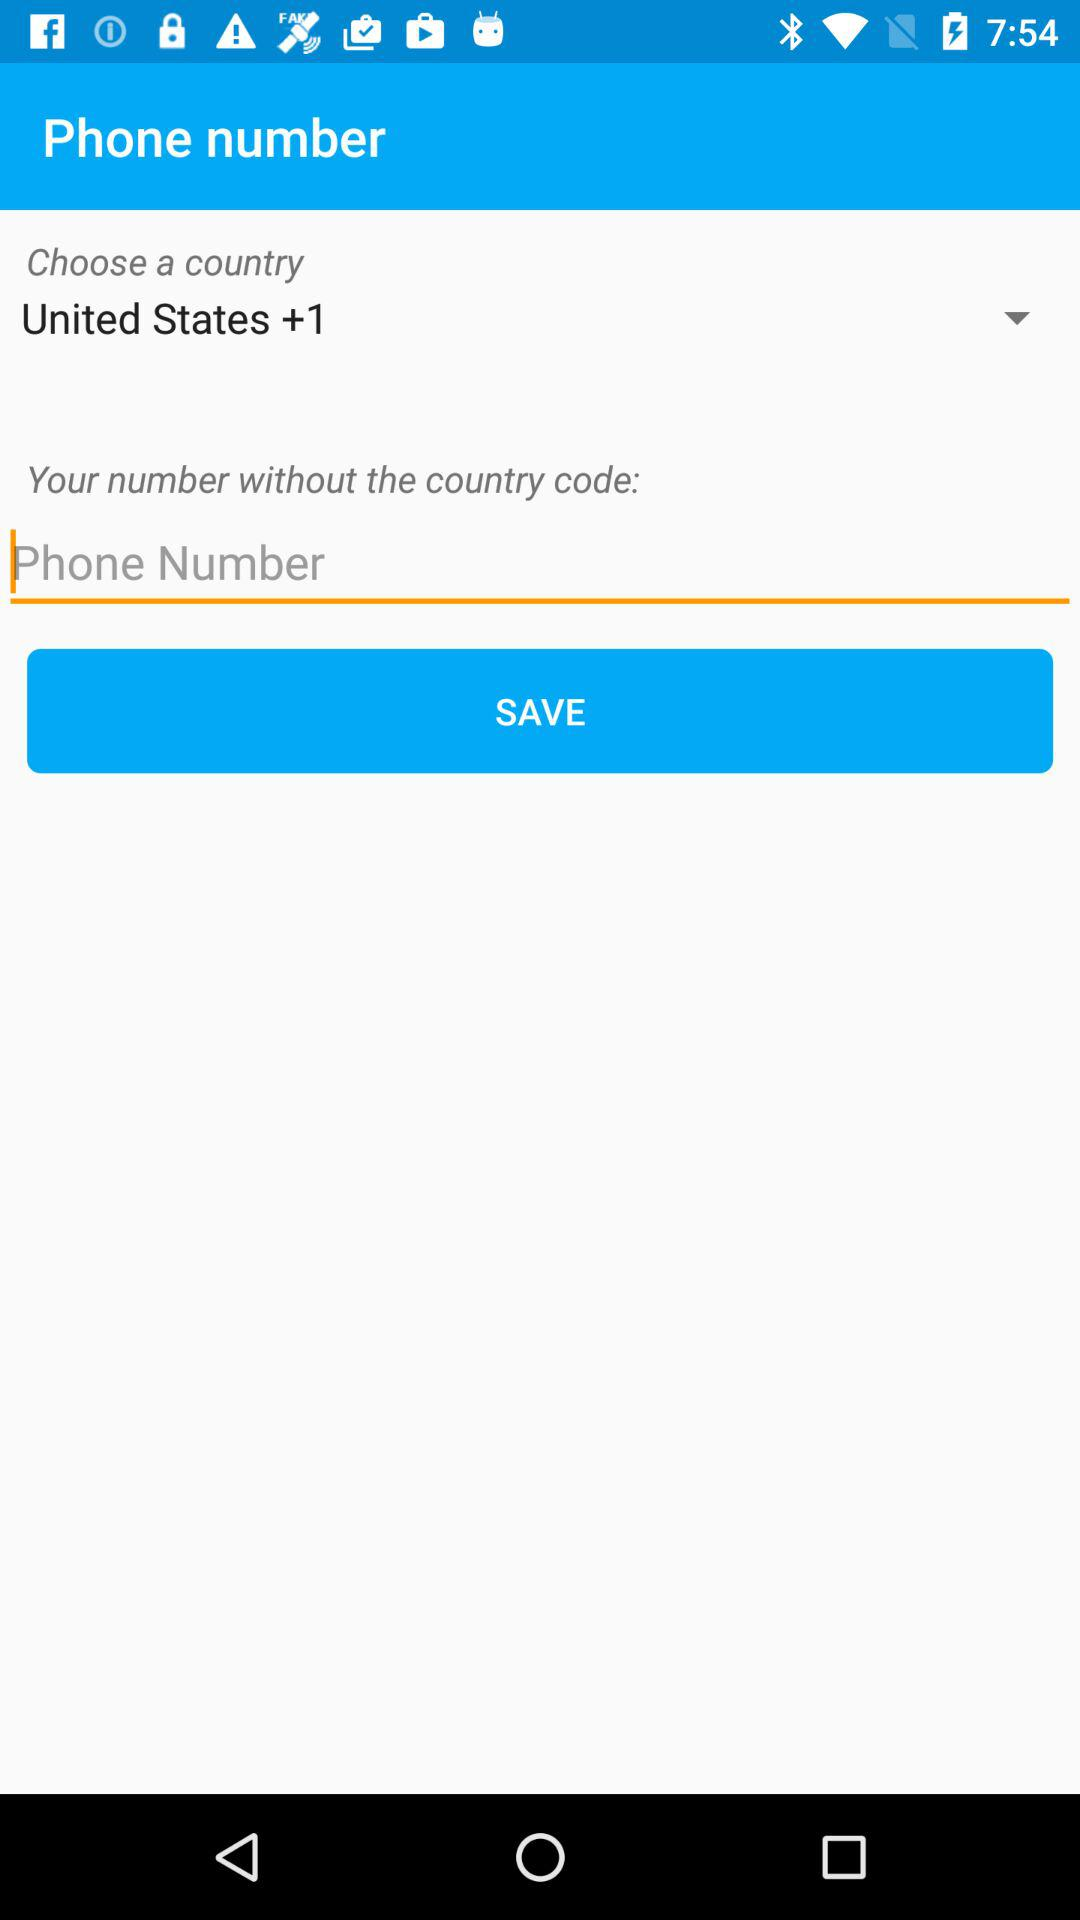How many digits are in the phone number without the country code?
Answer the question using a single word or phrase. 10 